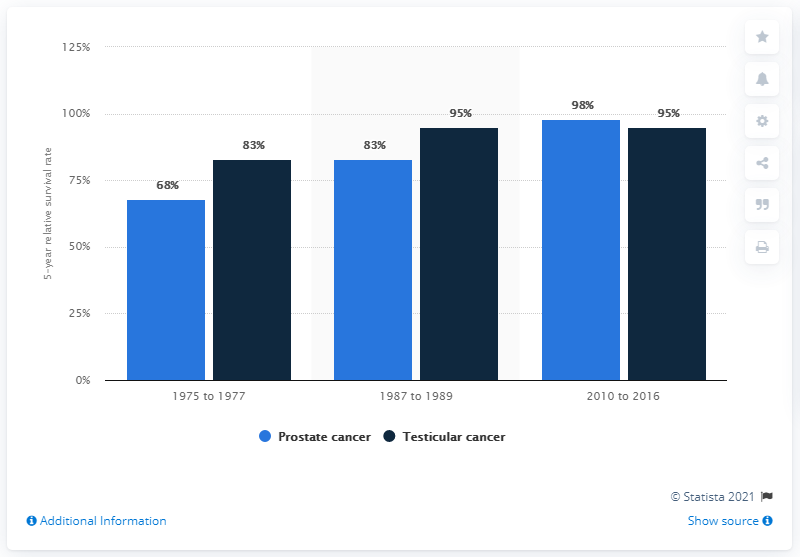Draw attention to some important aspects in this diagram. The statistical probability that a male would survive the first five years after a diagnosis was 98%. 